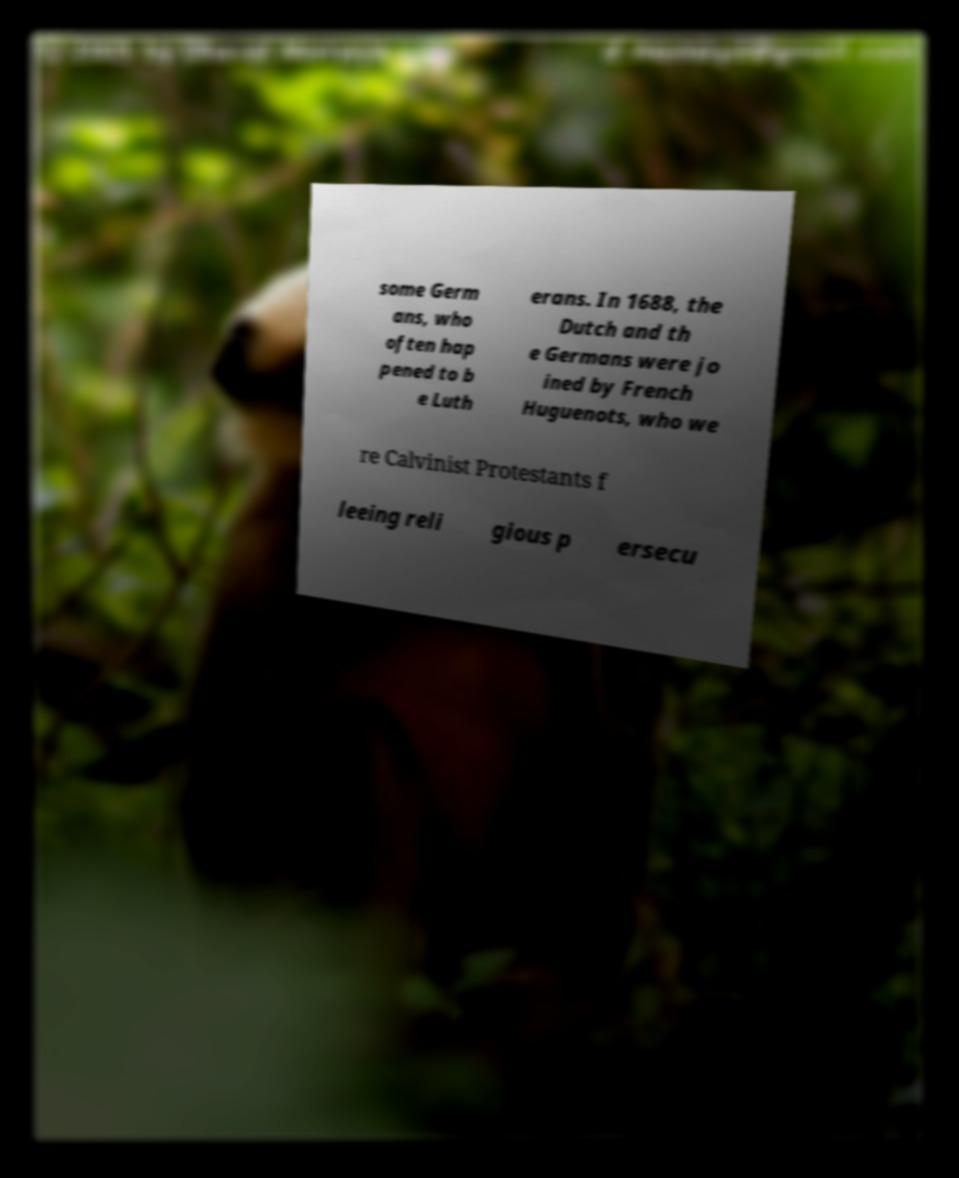I need the written content from this picture converted into text. Can you do that? some Germ ans, who often hap pened to b e Luth erans. In 1688, the Dutch and th e Germans were jo ined by French Huguenots, who we re Calvinist Protestants f leeing reli gious p ersecu 